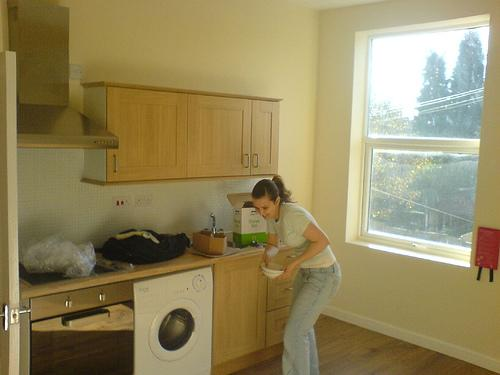What is the woman using the bowl for here? Please explain your reasoning. feed pet. Looks like she may be feeding a pet with it. 